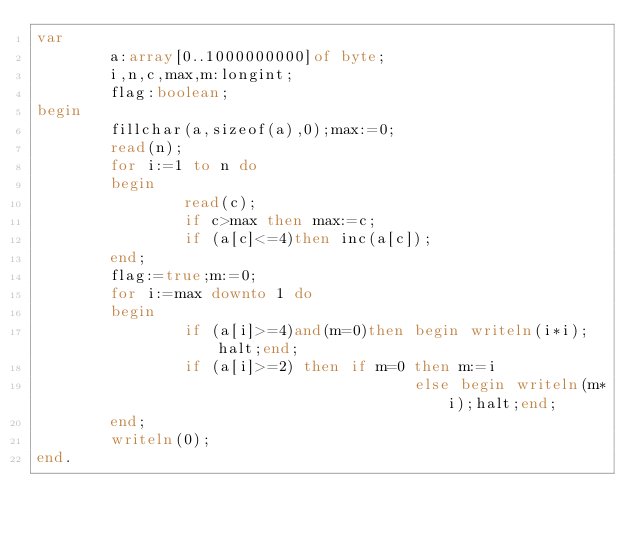<code> <loc_0><loc_0><loc_500><loc_500><_Pascal_>var
        a:array[0..1000000000]of byte;
        i,n,c,max,m:longint;
        flag:boolean;
begin
        fillchar(a,sizeof(a),0);max:=0;
        read(n);
        for i:=1 to n do
        begin
                read(c);
                if c>max then max:=c;
                if (a[c]<=4)then inc(a[c]);
        end;
        flag:=true;m:=0;
        for i:=max downto 1 do
        begin
                if (a[i]>=4)and(m=0)then begin writeln(i*i);halt;end;
                if (a[i]>=2) then if m=0 then m:=i
                                         else begin writeln(m*i);halt;end;
        end;
        writeln(0);
end. 
</code> 